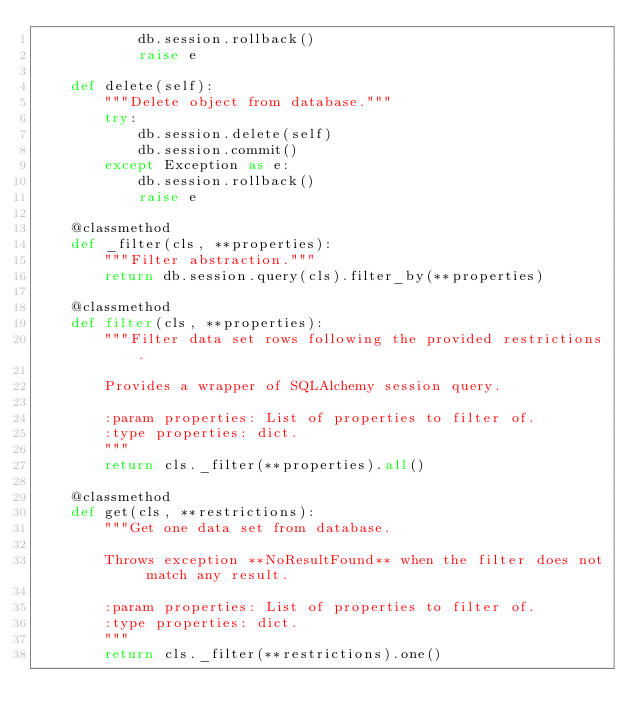Convert code to text. <code><loc_0><loc_0><loc_500><loc_500><_Python_>            db.session.rollback()
            raise e

    def delete(self):
        """Delete object from database."""
        try:
            db.session.delete(self)
            db.session.commit()
        except Exception as e:
            db.session.rollback()
            raise e

    @classmethod
    def _filter(cls, **properties):
        """Filter abstraction."""
        return db.session.query(cls).filter_by(**properties)

    @classmethod
    def filter(cls, **properties):
        """Filter data set rows following the provided restrictions.

        Provides a wrapper of SQLAlchemy session query.

        :param properties: List of properties to filter of.
        :type properties: dict.
        """
        return cls._filter(**properties).all()

    @classmethod
    def get(cls, **restrictions):
        """Get one data set from database.

        Throws exception **NoResultFound** when the filter does not match any result.

        :param properties: List of properties to filter of.
        :type properties: dict.
        """
        return cls._filter(**restrictions).one()
</code> 